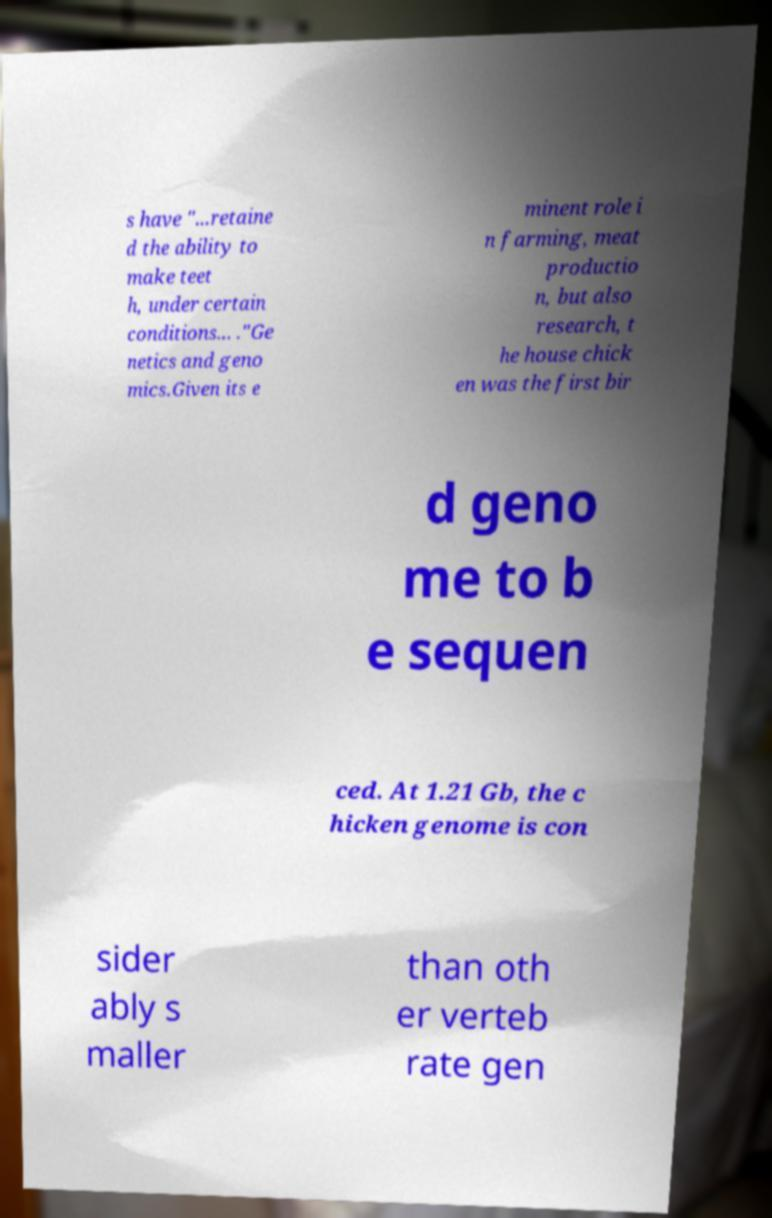Please identify and transcribe the text found in this image. s have "...retaine d the ability to make teet h, under certain conditions... ."Ge netics and geno mics.Given its e minent role i n farming, meat productio n, but also research, t he house chick en was the first bir d geno me to b e sequen ced. At 1.21 Gb, the c hicken genome is con sider ably s maller than oth er verteb rate gen 